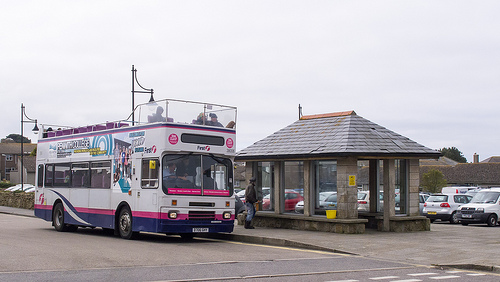On which side is the car? The car is on the right side. 